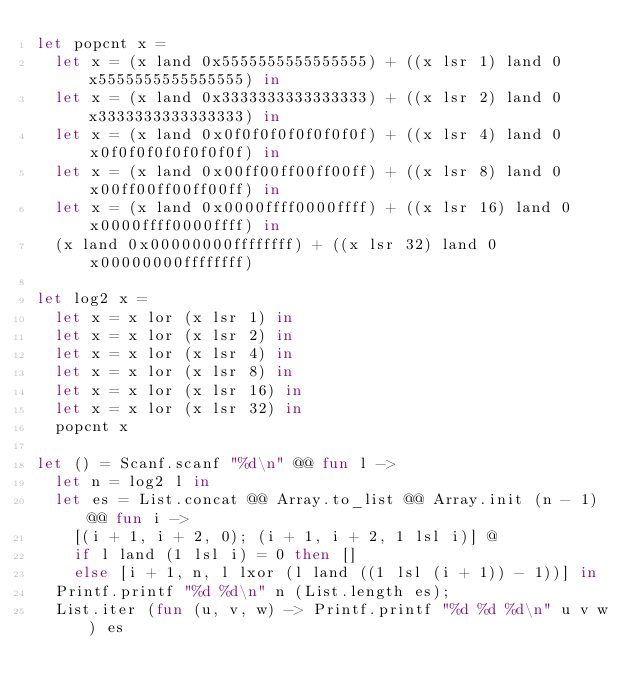<code> <loc_0><loc_0><loc_500><loc_500><_OCaml_>let popcnt x =
  let x = (x land 0x5555555555555555) + ((x lsr 1) land 0x5555555555555555) in
  let x = (x land 0x3333333333333333) + ((x lsr 2) land 0x3333333333333333) in
  let x = (x land 0x0f0f0f0f0f0f0f0f) + ((x lsr 4) land 0x0f0f0f0f0f0f0f0f) in
  let x = (x land 0x00ff00ff00ff00ff) + ((x lsr 8) land 0x00ff00ff00ff00ff) in
  let x = (x land 0x0000ffff0000ffff) + ((x lsr 16) land 0x0000ffff0000ffff) in
  (x land 0x00000000ffffffff) + ((x lsr 32) land 0x00000000ffffffff)

let log2 x =
  let x = x lor (x lsr 1) in
  let x = x lor (x lsr 2) in
  let x = x lor (x lsr 4) in
  let x = x lor (x lsr 8) in
  let x = x lor (x lsr 16) in
  let x = x lor (x lsr 32) in
  popcnt x

let () = Scanf.scanf "%d\n" @@ fun l ->
  let n = log2 l in
  let es = List.concat @@ Array.to_list @@ Array.init (n - 1) @@ fun i ->
    [(i + 1, i + 2, 0); (i + 1, i + 2, 1 lsl i)] @
    if l land (1 lsl i) = 0 then []
    else [i + 1, n, l lxor (l land ((1 lsl (i + 1)) - 1))] in
  Printf.printf "%d %d\n" n (List.length es);
  List.iter (fun (u, v, w) -> Printf.printf "%d %d %d\n" u v w) es

</code> 